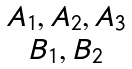Convert formula to latex. <formula><loc_0><loc_0><loc_500><loc_500>\begin{matrix} { A _ { 1 } , A _ { 2 } , A _ { 3 } } \\ { B _ { 1 } , B _ { 2 } } \end{matrix}</formula> 